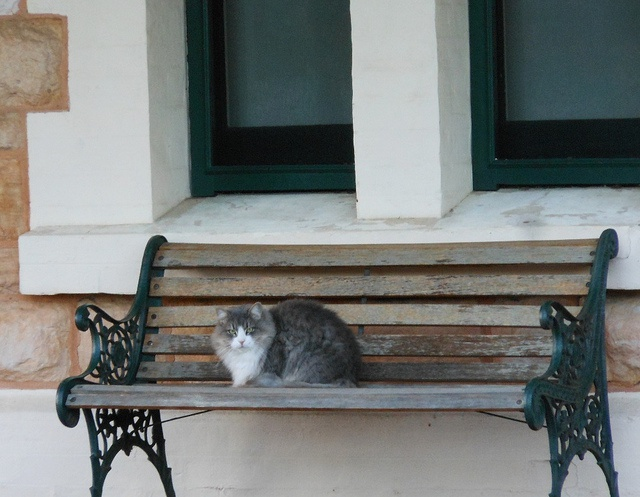Describe the objects in this image and their specific colors. I can see bench in darkgray, gray, and black tones and cat in darkgray, black, gray, and purple tones in this image. 